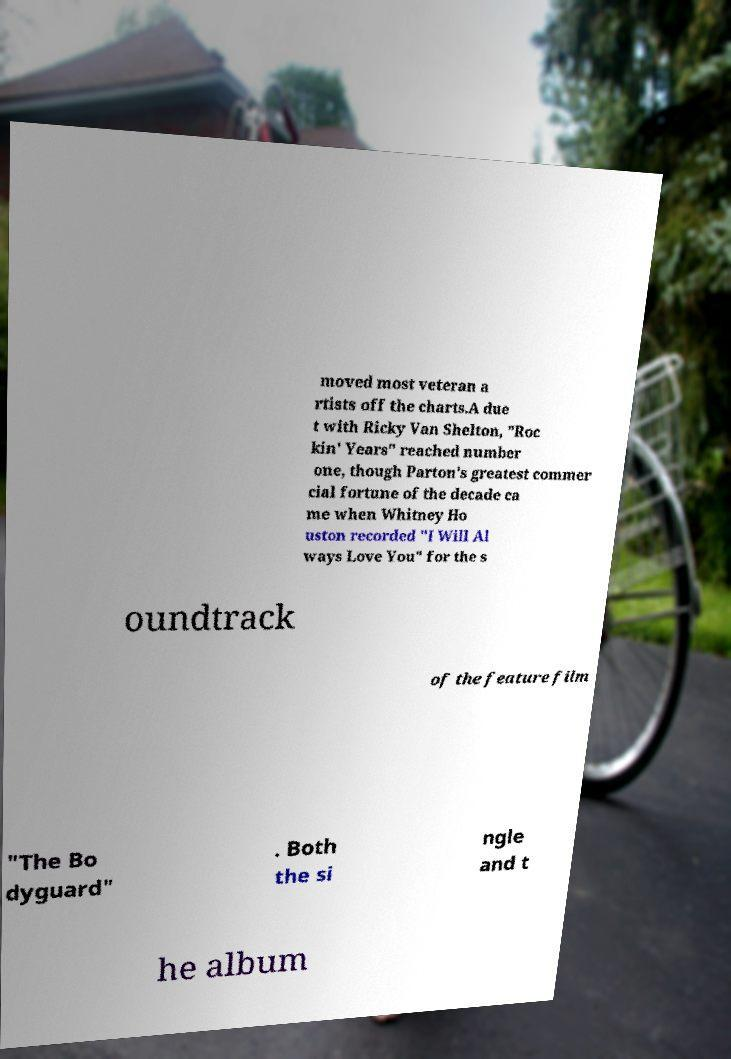I need the written content from this picture converted into text. Can you do that? moved most veteran a rtists off the charts.A due t with Ricky Van Shelton, "Roc kin' Years" reached number one, though Parton's greatest commer cial fortune of the decade ca me when Whitney Ho uston recorded "I Will Al ways Love You" for the s oundtrack of the feature film "The Bo dyguard" . Both the si ngle and t he album 